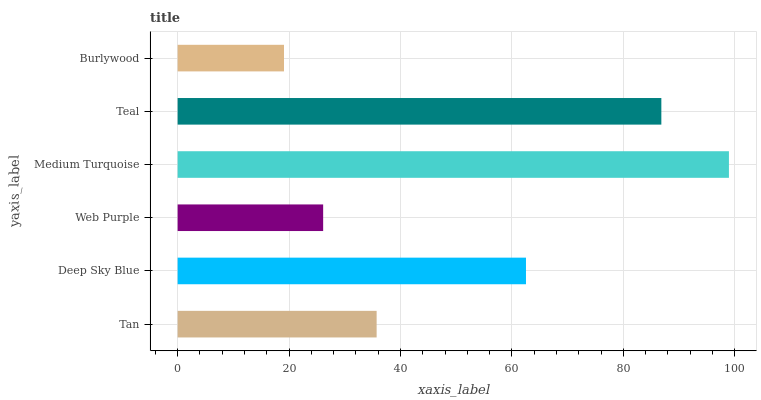Is Burlywood the minimum?
Answer yes or no. Yes. Is Medium Turquoise the maximum?
Answer yes or no. Yes. Is Deep Sky Blue the minimum?
Answer yes or no. No. Is Deep Sky Blue the maximum?
Answer yes or no. No. Is Deep Sky Blue greater than Tan?
Answer yes or no. Yes. Is Tan less than Deep Sky Blue?
Answer yes or no. Yes. Is Tan greater than Deep Sky Blue?
Answer yes or no. No. Is Deep Sky Blue less than Tan?
Answer yes or no. No. Is Deep Sky Blue the high median?
Answer yes or no. Yes. Is Tan the low median?
Answer yes or no. Yes. Is Burlywood the high median?
Answer yes or no. No. Is Burlywood the low median?
Answer yes or no. No. 